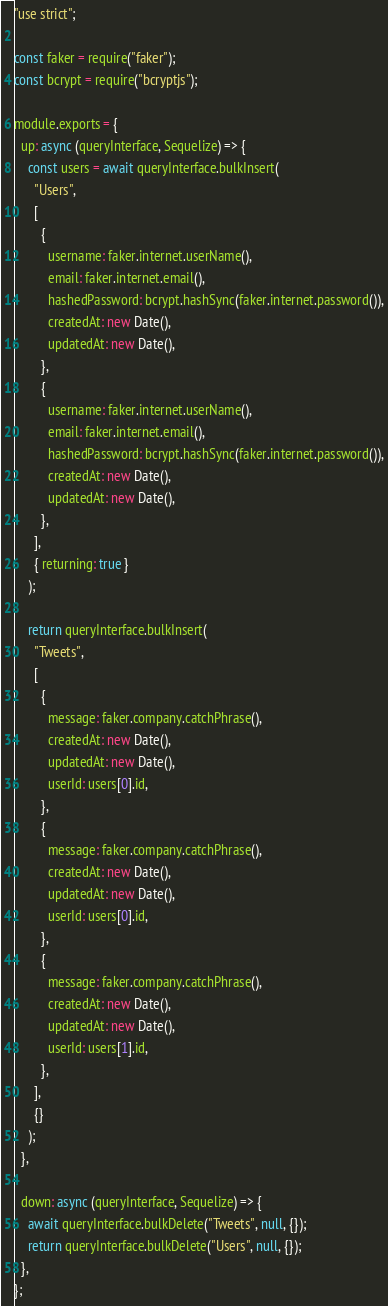<code> <loc_0><loc_0><loc_500><loc_500><_JavaScript_>"use strict";

const faker = require("faker");
const bcrypt = require("bcryptjs");

module.exports = {
  up: async (queryInterface, Sequelize) => {
    const users = await queryInterface.bulkInsert(
      "Users",
      [
        {
          username: faker.internet.userName(),
          email: faker.internet.email(),
          hashedPassword: bcrypt.hashSync(faker.internet.password()),
          createdAt: new Date(),
          updatedAt: new Date(),
        },
        {
          username: faker.internet.userName(),
          email: faker.internet.email(),
          hashedPassword: bcrypt.hashSync(faker.internet.password()),
          createdAt: new Date(),
          updatedAt: new Date(),
        },
      ],
      { returning: true }
    );

    return queryInterface.bulkInsert(
      "Tweets",
      [
        {
          message: faker.company.catchPhrase(),
          createdAt: new Date(),
          updatedAt: new Date(),
          userId: users[0].id,
        },
        {
          message: faker.company.catchPhrase(),
          createdAt: new Date(),
          updatedAt: new Date(),
          userId: users[0].id,
        },
        {
          message: faker.company.catchPhrase(),
          createdAt: new Date(),
          updatedAt: new Date(),
          userId: users[1].id,
        },
      ],
      {}
    );
  },

  down: async (queryInterface, Sequelize) => {
    await queryInterface.bulkDelete("Tweets", null, {});
    return queryInterface.bulkDelete("Users", null, {});
  },
};
</code> 